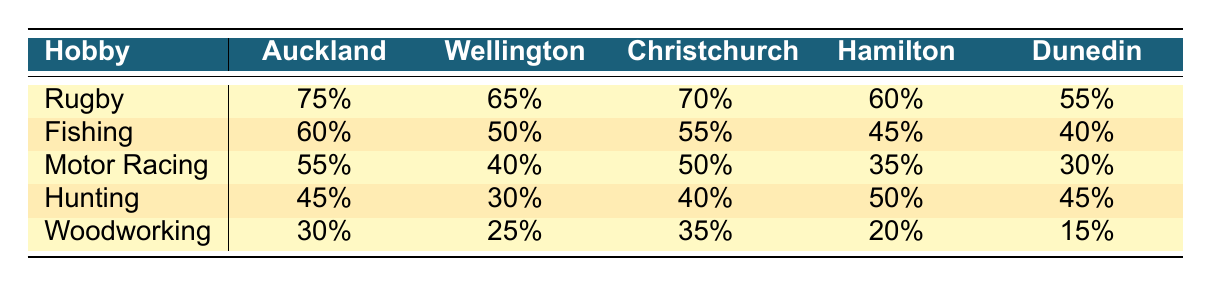What is the highest percentage of participation in rugby by region? By examining the rugby row in the table, we can see that Auckland has the highest percentage at 75%.
Answer: 75% Which region has the lowest participation in woodworking? Looking at the woodworking row, Dunedin has the lowest percentage at 15%.
Answer: 15% How does the fishing participation in Wellington compare to that in Christchurch? Wellington has a fishing participation rate of 50%, while Christchurch has a rate of 55%. Therefore, Christchurch has a higher rate by 5%.
Answer: Christchurch has a higher rate What is the total participation percentage for hunting across all regions? We will sum the hunting percentages from each region: 45 + 30 + 40 + 50 + 45 = 210. Therefore, the total participation for hunting is 210%.
Answer: 210% Is the participation percentage for motor racing higher in Hamilton than in Auckland? Hamilton has a motor racing participation of 35%, while Auckland has 55%. Since 35% is less than 55%, the statement is false.
Answer: No What is the average percentage of participation in rugby across all regions? The total rugby participation is 75 + 65 + 70 + 60 + 55 = 325. There are 5 regions, so the average is 325 / 5 = 65%.
Answer: 65% Which region has the highest overall participation in all the hobbies combined? To find the region with the highest overall participation, we calculate the total for each region: Auckland (75 + 60 + 55 + 45 + 30 = 265), Wellington (65 + 50 + 40 + 30 + 25 = 210), Christchurch (70 + 55 + 50 + 40 + 35 = 250), Hamilton (60 + 45 + 35 + 50 + 20 = 210), and Dunedin (55 + 40 + 30 + 45 + 15 = 185). Auckland has the highest with 265.
Answer: Auckland Is the fishing participation in Dunedin above 40%? From the table, Dunedin's fishing participation is 40%, which means it is not above 40%. Therefore, the statement is false.
Answer: No Which hobby has the closest participation rates between Hamilton and Christchurch? We compare each hobby's rates between Hamilton and Christchurch: Rugby (60 vs 70), Fishing (45 vs 55), Motor Racing (35 vs 50), Hunting (50 vs 40), Woodworking (20 vs 35). The hobby with the closest rates is hunting at 50% for Hamilton and 40% for Christchurch (only a 10% difference).
Answer: Hunting 